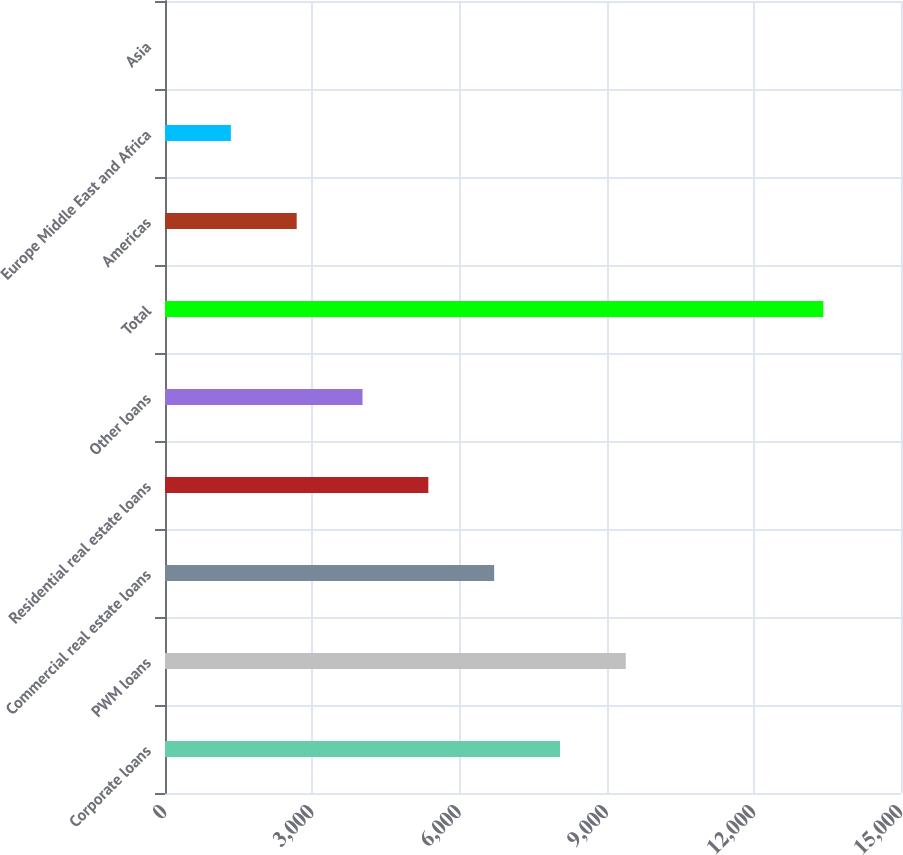Convert chart. <chart><loc_0><loc_0><loc_500><loc_500><bar_chart><fcel>Corporate loans<fcel>PWM loans<fcel>Commercial real estate loans<fcel>Residential real estate loans<fcel>Other loans<fcel>Total<fcel>Americas<fcel>Europe Middle East and Africa<fcel>Asia<nl><fcel>8050<fcel>9391.5<fcel>6708.5<fcel>5367<fcel>4025.5<fcel>13416<fcel>2684<fcel>1342.5<fcel>1<nl></chart> 